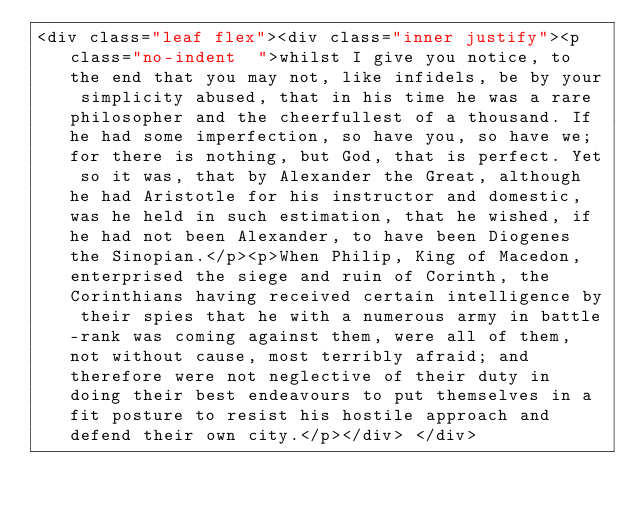<code> <loc_0><loc_0><loc_500><loc_500><_HTML_><div class="leaf flex"><div class="inner justify"><p class="no-indent  ">whilst I give you notice, to the end that you may not, like infidels, be by your simplicity abused, that in his time he was a rare philosopher and the cheerfullest of a thousand. If he had some imperfection, so have you, so have we; for there is nothing, but God, that is perfect. Yet so it was, that by Alexander the Great, although he had Aristotle for his instructor and domestic, was he held in such estimation, that he wished, if he had not been Alexander, to have been Diogenes the Sinopian.</p><p>When Philip, King of Macedon, enterprised the siege and ruin of Corinth, the Corinthians having received certain intelligence by their spies that he with a numerous army in battle-rank was coming against them, were all of them, not without cause, most terribly afraid; and therefore were not neglective of their duty in doing their best endeavours to put themselves in a fit posture to resist his hostile approach and defend their own city.</p></div> </div></code> 